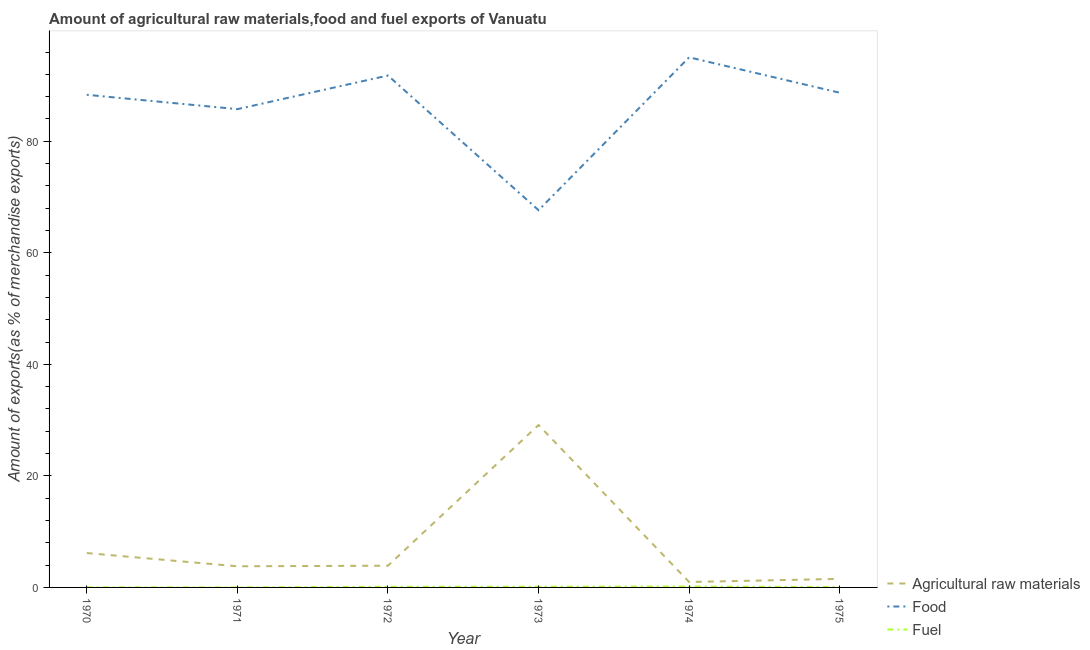How many different coloured lines are there?
Keep it short and to the point. 3. Is the number of lines equal to the number of legend labels?
Your response must be concise. Yes. What is the percentage of food exports in 1973?
Offer a terse response. 67.64. Across all years, what is the maximum percentage of raw materials exports?
Your answer should be compact. 29.12. Across all years, what is the minimum percentage of raw materials exports?
Offer a very short reply. 0.97. In which year was the percentage of fuel exports minimum?
Provide a short and direct response. 1971. What is the total percentage of raw materials exports in the graph?
Your response must be concise. 45.48. What is the difference between the percentage of raw materials exports in 1973 and that in 1974?
Your answer should be very brief. 28.15. What is the difference between the percentage of raw materials exports in 1973 and the percentage of fuel exports in 1972?
Your answer should be compact. 29.01. What is the average percentage of raw materials exports per year?
Ensure brevity in your answer.  7.58. In the year 1975, what is the difference between the percentage of food exports and percentage of fuel exports?
Give a very brief answer. 88.64. In how many years, is the percentage of fuel exports greater than 80 %?
Give a very brief answer. 0. What is the ratio of the percentage of food exports in 1971 to that in 1975?
Your answer should be very brief. 0.97. What is the difference between the highest and the second highest percentage of fuel exports?
Provide a succinct answer. 0.03. What is the difference between the highest and the lowest percentage of fuel exports?
Offer a very short reply. 0.17. In how many years, is the percentage of fuel exports greater than the average percentage of fuel exports taken over all years?
Offer a terse response. 3. Is the sum of the percentage of fuel exports in 1970 and 1975 greater than the maximum percentage of raw materials exports across all years?
Keep it short and to the point. No. Does the percentage of food exports monotonically increase over the years?
Offer a very short reply. No. Is the percentage of fuel exports strictly greater than the percentage of raw materials exports over the years?
Keep it short and to the point. No. How many lines are there?
Provide a short and direct response. 3. Does the graph contain any zero values?
Offer a very short reply. No. Does the graph contain grids?
Ensure brevity in your answer.  No. Where does the legend appear in the graph?
Provide a succinct answer. Bottom right. How are the legend labels stacked?
Make the answer very short. Vertical. What is the title of the graph?
Ensure brevity in your answer.  Amount of agricultural raw materials,food and fuel exports of Vanuatu. What is the label or title of the Y-axis?
Keep it short and to the point. Amount of exports(as % of merchandise exports). What is the Amount of exports(as % of merchandise exports) in Agricultural raw materials in 1970?
Make the answer very short. 6.16. What is the Amount of exports(as % of merchandise exports) in Food in 1970?
Offer a very short reply. 88.33. What is the Amount of exports(as % of merchandise exports) of Fuel in 1970?
Make the answer very short. 0.02. What is the Amount of exports(as % of merchandise exports) in Agricultural raw materials in 1971?
Offer a very short reply. 3.79. What is the Amount of exports(as % of merchandise exports) of Food in 1971?
Ensure brevity in your answer.  85.76. What is the Amount of exports(as % of merchandise exports) in Fuel in 1971?
Offer a very short reply. 0. What is the Amount of exports(as % of merchandise exports) of Agricultural raw materials in 1972?
Provide a short and direct response. 3.9. What is the Amount of exports(as % of merchandise exports) in Food in 1972?
Make the answer very short. 91.79. What is the Amount of exports(as % of merchandise exports) of Fuel in 1972?
Keep it short and to the point. 0.12. What is the Amount of exports(as % of merchandise exports) in Agricultural raw materials in 1973?
Provide a short and direct response. 29.12. What is the Amount of exports(as % of merchandise exports) in Food in 1973?
Provide a succinct answer. 67.64. What is the Amount of exports(as % of merchandise exports) in Fuel in 1973?
Keep it short and to the point. 0.14. What is the Amount of exports(as % of merchandise exports) of Agricultural raw materials in 1974?
Provide a succinct answer. 0.97. What is the Amount of exports(as % of merchandise exports) of Food in 1974?
Ensure brevity in your answer.  95.05. What is the Amount of exports(as % of merchandise exports) of Fuel in 1974?
Your response must be concise. 0.17. What is the Amount of exports(as % of merchandise exports) of Agricultural raw materials in 1975?
Your answer should be compact. 1.53. What is the Amount of exports(as % of merchandise exports) in Food in 1975?
Offer a very short reply. 88.7. What is the Amount of exports(as % of merchandise exports) in Fuel in 1975?
Make the answer very short. 0.07. Across all years, what is the maximum Amount of exports(as % of merchandise exports) of Agricultural raw materials?
Make the answer very short. 29.12. Across all years, what is the maximum Amount of exports(as % of merchandise exports) in Food?
Provide a succinct answer. 95.05. Across all years, what is the maximum Amount of exports(as % of merchandise exports) in Fuel?
Provide a short and direct response. 0.17. Across all years, what is the minimum Amount of exports(as % of merchandise exports) of Agricultural raw materials?
Give a very brief answer. 0.97. Across all years, what is the minimum Amount of exports(as % of merchandise exports) of Food?
Offer a very short reply. 67.64. Across all years, what is the minimum Amount of exports(as % of merchandise exports) in Fuel?
Offer a very short reply. 0. What is the total Amount of exports(as % of merchandise exports) of Agricultural raw materials in the graph?
Your answer should be very brief. 45.48. What is the total Amount of exports(as % of merchandise exports) in Food in the graph?
Provide a succinct answer. 517.29. What is the total Amount of exports(as % of merchandise exports) in Fuel in the graph?
Offer a very short reply. 0.51. What is the difference between the Amount of exports(as % of merchandise exports) in Agricultural raw materials in 1970 and that in 1971?
Make the answer very short. 2.37. What is the difference between the Amount of exports(as % of merchandise exports) in Food in 1970 and that in 1971?
Offer a terse response. 2.57. What is the difference between the Amount of exports(as % of merchandise exports) of Fuel in 1970 and that in 1971?
Ensure brevity in your answer.  0.02. What is the difference between the Amount of exports(as % of merchandise exports) in Agricultural raw materials in 1970 and that in 1972?
Ensure brevity in your answer.  2.27. What is the difference between the Amount of exports(as % of merchandise exports) of Food in 1970 and that in 1972?
Ensure brevity in your answer.  -3.46. What is the difference between the Amount of exports(as % of merchandise exports) in Fuel in 1970 and that in 1972?
Your answer should be very brief. -0.1. What is the difference between the Amount of exports(as % of merchandise exports) in Agricultural raw materials in 1970 and that in 1973?
Provide a short and direct response. -22.96. What is the difference between the Amount of exports(as % of merchandise exports) in Food in 1970 and that in 1973?
Your response must be concise. 20.69. What is the difference between the Amount of exports(as % of merchandise exports) in Fuel in 1970 and that in 1973?
Provide a short and direct response. -0.12. What is the difference between the Amount of exports(as % of merchandise exports) in Agricultural raw materials in 1970 and that in 1974?
Your answer should be compact. 5.19. What is the difference between the Amount of exports(as % of merchandise exports) of Food in 1970 and that in 1974?
Provide a short and direct response. -6.72. What is the difference between the Amount of exports(as % of merchandise exports) of Fuel in 1970 and that in 1974?
Provide a succinct answer. -0.15. What is the difference between the Amount of exports(as % of merchandise exports) in Agricultural raw materials in 1970 and that in 1975?
Your response must be concise. 4.63. What is the difference between the Amount of exports(as % of merchandise exports) of Food in 1970 and that in 1975?
Your answer should be very brief. -0.37. What is the difference between the Amount of exports(as % of merchandise exports) in Fuel in 1970 and that in 1975?
Provide a succinct answer. -0.05. What is the difference between the Amount of exports(as % of merchandise exports) in Agricultural raw materials in 1971 and that in 1972?
Ensure brevity in your answer.  -0.11. What is the difference between the Amount of exports(as % of merchandise exports) of Food in 1971 and that in 1972?
Offer a very short reply. -6.03. What is the difference between the Amount of exports(as % of merchandise exports) in Fuel in 1971 and that in 1972?
Your answer should be compact. -0.11. What is the difference between the Amount of exports(as % of merchandise exports) of Agricultural raw materials in 1971 and that in 1973?
Your response must be concise. -25.33. What is the difference between the Amount of exports(as % of merchandise exports) of Food in 1971 and that in 1973?
Ensure brevity in your answer.  18.12. What is the difference between the Amount of exports(as % of merchandise exports) of Fuel in 1971 and that in 1973?
Offer a very short reply. -0.13. What is the difference between the Amount of exports(as % of merchandise exports) in Agricultural raw materials in 1971 and that in 1974?
Ensure brevity in your answer.  2.82. What is the difference between the Amount of exports(as % of merchandise exports) in Food in 1971 and that in 1974?
Provide a succinct answer. -9.29. What is the difference between the Amount of exports(as % of merchandise exports) of Fuel in 1971 and that in 1974?
Give a very brief answer. -0.17. What is the difference between the Amount of exports(as % of merchandise exports) in Agricultural raw materials in 1971 and that in 1975?
Your response must be concise. 2.26. What is the difference between the Amount of exports(as % of merchandise exports) in Food in 1971 and that in 1975?
Offer a very short reply. -2.94. What is the difference between the Amount of exports(as % of merchandise exports) of Fuel in 1971 and that in 1975?
Provide a succinct answer. -0.07. What is the difference between the Amount of exports(as % of merchandise exports) of Agricultural raw materials in 1972 and that in 1973?
Make the answer very short. -25.23. What is the difference between the Amount of exports(as % of merchandise exports) of Food in 1972 and that in 1973?
Give a very brief answer. 24.15. What is the difference between the Amount of exports(as % of merchandise exports) in Fuel in 1972 and that in 1973?
Keep it short and to the point. -0.02. What is the difference between the Amount of exports(as % of merchandise exports) of Agricultural raw materials in 1972 and that in 1974?
Your answer should be compact. 2.93. What is the difference between the Amount of exports(as % of merchandise exports) in Food in 1972 and that in 1974?
Ensure brevity in your answer.  -3.26. What is the difference between the Amount of exports(as % of merchandise exports) of Fuel in 1972 and that in 1974?
Your answer should be compact. -0.05. What is the difference between the Amount of exports(as % of merchandise exports) in Agricultural raw materials in 1972 and that in 1975?
Your response must be concise. 2.36. What is the difference between the Amount of exports(as % of merchandise exports) of Food in 1972 and that in 1975?
Provide a short and direct response. 3.09. What is the difference between the Amount of exports(as % of merchandise exports) of Fuel in 1972 and that in 1975?
Provide a succinct answer. 0.05. What is the difference between the Amount of exports(as % of merchandise exports) in Agricultural raw materials in 1973 and that in 1974?
Offer a terse response. 28.15. What is the difference between the Amount of exports(as % of merchandise exports) of Food in 1973 and that in 1974?
Provide a short and direct response. -27.41. What is the difference between the Amount of exports(as % of merchandise exports) in Fuel in 1973 and that in 1974?
Your answer should be compact. -0.03. What is the difference between the Amount of exports(as % of merchandise exports) of Agricultural raw materials in 1973 and that in 1975?
Your response must be concise. 27.59. What is the difference between the Amount of exports(as % of merchandise exports) of Food in 1973 and that in 1975?
Your answer should be very brief. -21.06. What is the difference between the Amount of exports(as % of merchandise exports) in Fuel in 1973 and that in 1975?
Your response must be concise. 0.07. What is the difference between the Amount of exports(as % of merchandise exports) of Agricultural raw materials in 1974 and that in 1975?
Offer a terse response. -0.56. What is the difference between the Amount of exports(as % of merchandise exports) in Food in 1974 and that in 1975?
Give a very brief answer. 6.35. What is the difference between the Amount of exports(as % of merchandise exports) of Fuel in 1974 and that in 1975?
Make the answer very short. 0.1. What is the difference between the Amount of exports(as % of merchandise exports) of Agricultural raw materials in 1970 and the Amount of exports(as % of merchandise exports) of Food in 1971?
Your answer should be compact. -79.6. What is the difference between the Amount of exports(as % of merchandise exports) in Agricultural raw materials in 1970 and the Amount of exports(as % of merchandise exports) in Fuel in 1971?
Offer a very short reply. 6.16. What is the difference between the Amount of exports(as % of merchandise exports) of Food in 1970 and the Amount of exports(as % of merchandise exports) of Fuel in 1971?
Ensure brevity in your answer.  88.33. What is the difference between the Amount of exports(as % of merchandise exports) in Agricultural raw materials in 1970 and the Amount of exports(as % of merchandise exports) in Food in 1972?
Keep it short and to the point. -85.63. What is the difference between the Amount of exports(as % of merchandise exports) of Agricultural raw materials in 1970 and the Amount of exports(as % of merchandise exports) of Fuel in 1972?
Your response must be concise. 6.05. What is the difference between the Amount of exports(as % of merchandise exports) in Food in 1970 and the Amount of exports(as % of merchandise exports) in Fuel in 1972?
Offer a terse response. 88.22. What is the difference between the Amount of exports(as % of merchandise exports) of Agricultural raw materials in 1970 and the Amount of exports(as % of merchandise exports) of Food in 1973?
Offer a terse response. -61.48. What is the difference between the Amount of exports(as % of merchandise exports) of Agricultural raw materials in 1970 and the Amount of exports(as % of merchandise exports) of Fuel in 1973?
Keep it short and to the point. 6.03. What is the difference between the Amount of exports(as % of merchandise exports) of Food in 1970 and the Amount of exports(as % of merchandise exports) of Fuel in 1973?
Your answer should be compact. 88.2. What is the difference between the Amount of exports(as % of merchandise exports) of Agricultural raw materials in 1970 and the Amount of exports(as % of merchandise exports) of Food in 1974?
Ensure brevity in your answer.  -88.89. What is the difference between the Amount of exports(as % of merchandise exports) in Agricultural raw materials in 1970 and the Amount of exports(as % of merchandise exports) in Fuel in 1974?
Your answer should be very brief. 6. What is the difference between the Amount of exports(as % of merchandise exports) of Food in 1970 and the Amount of exports(as % of merchandise exports) of Fuel in 1974?
Your answer should be very brief. 88.17. What is the difference between the Amount of exports(as % of merchandise exports) of Agricultural raw materials in 1970 and the Amount of exports(as % of merchandise exports) of Food in 1975?
Your answer should be very brief. -82.54. What is the difference between the Amount of exports(as % of merchandise exports) in Agricultural raw materials in 1970 and the Amount of exports(as % of merchandise exports) in Fuel in 1975?
Provide a short and direct response. 6.1. What is the difference between the Amount of exports(as % of merchandise exports) of Food in 1970 and the Amount of exports(as % of merchandise exports) of Fuel in 1975?
Your response must be concise. 88.27. What is the difference between the Amount of exports(as % of merchandise exports) in Agricultural raw materials in 1971 and the Amount of exports(as % of merchandise exports) in Food in 1972?
Offer a terse response. -88. What is the difference between the Amount of exports(as % of merchandise exports) of Agricultural raw materials in 1971 and the Amount of exports(as % of merchandise exports) of Fuel in 1972?
Provide a succinct answer. 3.67. What is the difference between the Amount of exports(as % of merchandise exports) of Food in 1971 and the Amount of exports(as % of merchandise exports) of Fuel in 1972?
Your answer should be compact. 85.65. What is the difference between the Amount of exports(as % of merchandise exports) in Agricultural raw materials in 1971 and the Amount of exports(as % of merchandise exports) in Food in 1973?
Offer a very short reply. -63.85. What is the difference between the Amount of exports(as % of merchandise exports) of Agricultural raw materials in 1971 and the Amount of exports(as % of merchandise exports) of Fuel in 1973?
Your response must be concise. 3.65. What is the difference between the Amount of exports(as % of merchandise exports) of Food in 1971 and the Amount of exports(as % of merchandise exports) of Fuel in 1973?
Make the answer very short. 85.63. What is the difference between the Amount of exports(as % of merchandise exports) of Agricultural raw materials in 1971 and the Amount of exports(as % of merchandise exports) of Food in 1974?
Your answer should be compact. -91.26. What is the difference between the Amount of exports(as % of merchandise exports) in Agricultural raw materials in 1971 and the Amount of exports(as % of merchandise exports) in Fuel in 1974?
Give a very brief answer. 3.62. What is the difference between the Amount of exports(as % of merchandise exports) in Food in 1971 and the Amount of exports(as % of merchandise exports) in Fuel in 1974?
Provide a succinct answer. 85.59. What is the difference between the Amount of exports(as % of merchandise exports) of Agricultural raw materials in 1971 and the Amount of exports(as % of merchandise exports) of Food in 1975?
Keep it short and to the point. -84.91. What is the difference between the Amount of exports(as % of merchandise exports) of Agricultural raw materials in 1971 and the Amount of exports(as % of merchandise exports) of Fuel in 1975?
Your answer should be very brief. 3.72. What is the difference between the Amount of exports(as % of merchandise exports) of Food in 1971 and the Amount of exports(as % of merchandise exports) of Fuel in 1975?
Ensure brevity in your answer.  85.69. What is the difference between the Amount of exports(as % of merchandise exports) of Agricultural raw materials in 1972 and the Amount of exports(as % of merchandise exports) of Food in 1973?
Offer a terse response. -63.75. What is the difference between the Amount of exports(as % of merchandise exports) in Agricultural raw materials in 1972 and the Amount of exports(as % of merchandise exports) in Fuel in 1973?
Make the answer very short. 3.76. What is the difference between the Amount of exports(as % of merchandise exports) of Food in 1972 and the Amount of exports(as % of merchandise exports) of Fuel in 1973?
Provide a succinct answer. 91.66. What is the difference between the Amount of exports(as % of merchandise exports) in Agricultural raw materials in 1972 and the Amount of exports(as % of merchandise exports) in Food in 1974?
Keep it short and to the point. -91.16. What is the difference between the Amount of exports(as % of merchandise exports) in Agricultural raw materials in 1972 and the Amount of exports(as % of merchandise exports) in Fuel in 1974?
Offer a terse response. 3.73. What is the difference between the Amount of exports(as % of merchandise exports) of Food in 1972 and the Amount of exports(as % of merchandise exports) of Fuel in 1974?
Provide a succinct answer. 91.62. What is the difference between the Amount of exports(as % of merchandise exports) in Agricultural raw materials in 1972 and the Amount of exports(as % of merchandise exports) in Food in 1975?
Ensure brevity in your answer.  -84.81. What is the difference between the Amount of exports(as % of merchandise exports) of Agricultural raw materials in 1972 and the Amount of exports(as % of merchandise exports) of Fuel in 1975?
Offer a terse response. 3.83. What is the difference between the Amount of exports(as % of merchandise exports) of Food in 1972 and the Amount of exports(as % of merchandise exports) of Fuel in 1975?
Your answer should be compact. 91.72. What is the difference between the Amount of exports(as % of merchandise exports) in Agricultural raw materials in 1973 and the Amount of exports(as % of merchandise exports) in Food in 1974?
Your response must be concise. -65.93. What is the difference between the Amount of exports(as % of merchandise exports) of Agricultural raw materials in 1973 and the Amount of exports(as % of merchandise exports) of Fuel in 1974?
Make the answer very short. 28.95. What is the difference between the Amount of exports(as % of merchandise exports) in Food in 1973 and the Amount of exports(as % of merchandise exports) in Fuel in 1974?
Make the answer very short. 67.47. What is the difference between the Amount of exports(as % of merchandise exports) in Agricultural raw materials in 1973 and the Amount of exports(as % of merchandise exports) in Food in 1975?
Give a very brief answer. -59.58. What is the difference between the Amount of exports(as % of merchandise exports) in Agricultural raw materials in 1973 and the Amount of exports(as % of merchandise exports) in Fuel in 1975?
Keep it short and to the point. 29.05. What is the difference between the Amount of exports(as % of merchandise exports) in Food in 1973 and the Amount of exports(as % of merchandise exports) in Fuel in 1975?
Your answer should be compact. 67.57. What is the difference between the Amount of exports(as % of merchandise exports) of Agricultural raw materials in 1974 and the Amount of exports(as % of merchandise exports) of Food in 1975?
Provide a short and direct response. -87.73. What is the difference between the Amount of exports(as % of merchandise exports) in Agricultural raw materials in 1974 and the Amount of exports(as % of merchandise exports) in Fuel in 1975?
Offer a very short reply. 0.9. What is the difference between the Amount of exports(as % of merchandise exports) in Food in 1974 and the Amount of exports(as % of merchandise exports) in Fuel in 1975?
Provide a succinct answer. 94.98. What is the average Amount of exports(as % of merchandise exports) of Agricultural raw materials per year?
Offer a terse response. 7.58. What is the average Amount of exports(as % of merchandise exports) in Food per year?
Ensure brevity in your answer.  86.21. What is the average Amount of exports(as % of merchandise exports) in Fuel per year?
Keep it short and to the point. 0.08. In the year 1970, what is the difference between the Amount of exports(as % of merchandise exports) in Agricultural raw materials and Amount of exports(as % of merchandise exports) in Food?
Provide a short and direct response. -82.17. In the year 1970, what is the difference between the Amount of exports(as % of merchandise exports) of Agricultural raw materials and Amount of exports(as % of merchandise exports) of Fuel?
Ensure brevity in your answer.  6.14. In the year 1970, what is the difference between the Amount of exports(as % of merchandise exports) in Food and Amount of exports(as % of merchandise exports) in Fuel?
Make the answer very short. 88.31. In the year 1971, what is the difference between the Amount of exports(as % of merchandise exports) of Agricultural raw materials and Amount of exports(as % of merchandise exports) of Food?
Your answer should be compact. -81.97. In the year 1971, what is the difference between the Amount of exports(as % of merchandise exports) of Agricultural raw materials and Amount of exports(as % of merchandise exports) of Fuel?
Your answer should be compact. 3.79. In the year 1971, what is the difference between the Amount of exports(as % of merchandise exports) of Food and Amount of exports(as % of merchandise exports) of Fuel?
Provide a succinct answer. 85.76. In the year 1972, what is the difference between the Amount of exports(as % of merchandise exports) of Agricultural raw materials and Amount of exports(as % of merchandise exports) of Food?
Offer a very short reply. -87.9. In the year 1972, what is the difference between the Amount of exports(as % of merchandise exports) of Agricultural raw materials and Amount of exports(as % of merchandise exports) of Fuel?
Ensure brevity in your answer.  3.78. In the year 1972, what is the difference between the Amount of exports(as % of merchandise exports) in Food and Amount of exports(as % of merchandise exports) in Fuel?
Keep it short and to the point. 91.68. In the year 1973, what is the difference between the Amount of exports(as % of merchandise exports) of Agricultural raw materials and Amount of exports(as % of merchandise exports) of Food?
Offer a terse response. -38.52. In the year 1973, what is the difference between the Amount of exports(as % of merchandise exports) in Agricultural raw materials and Amount of exports(as % of merchandise exports) in Fuel?
Ensure brevity in your answer.  28.99. In the year 1973, what is the difference between the Amount of exports(as % of merchandise exports) of Food and Amount of exports(as % of merchandise exports) of Fuel?
Ensure brevity in your answer.  67.51. In the year 1974, what is the difference between the Amount of exports(as % of merchandise exports) in Agricultural raw materials and Amount of exports(as % of merchandise exports) in Food?
Keep it short and to the point. -94.08. In the year 1974, what is the difference between the Amount of exports(as % of merchandise exports) in Agricultural raw materials and Amount of exports(as % of merchandise exports) in Fuel?
Provide a short and direct response. 0.8. In the year 1974, what is the difference between the Amount of exports(as % of merchandise exports) in Food and Amount of exports(as % of merchandise exports) in Fuel?
Your answer should be compact. 94.88. In the year 1975, what is the difference between the Amount of exports(as % of merchandise exports) of Agricultural raw materials and Amount of exports(as % of merchandise exports) of Food?
Offer a terse response. -87.17. In the year 1975, what is the difference between the Amount of exports(as % of merchandise exports) of Agricultural raw materials and Amount of exports(as % of merchandise exports) of Fuel?
Make the answer very short. 1.46. In the year 1975, what is the difference between the Amount of exports(as % of merchandise exports) of Food and Amount of exports(as % of merchandise exports) of Fuel?
Offer a very short reply. 88.64. What is the ratio of the Amount of exports(as % of merchandise exports) of Agricultural raw materials in 1970 to that in 1971?
Offer a terse response. 1.63. What is the ratio of the Amount of exports(as % of merchandise exports) in Fuel in 1970 to that in 1971?
Give a very brief answer. 10.53. What is the ratio of the Amount of exports(as % of merchandise exports) in Agricultural raw materials in 1970 to that in 1972?
Keep it short and to the point. 1.58. What is the ratio of the Amount of exports(as % of merchandise exports) in Food in 1970 to that in 1972?
Your answer should be very brief. 0.96. What is the ratio of the Amount of exports(as % of merchandise exports) of Fuel in 1970 to that in 1972?
Offer a very short reply. 0.17. What is the ratio of the Amount of exports(as % of merchandise exports) in Agricultural raw materials in 1970 to that in 1973?
Give a very brief answer. 0.21. What is the ratio of the Amount of exports(as % of merchandise exports) in Food in 1970 to that in 1973?
Keep it short and to the point. 1.31. What is the ratio of the Amount of exports(as % of merchandise exports) in Fuel in 1970 to that in 1973?
Offer a very short reply. 0.14. What is the ratio of the Amount of exports(as % of merchandise exports) of Agricultural raw materials in 1970 to that in 1974?
Give a very brief answer. 6.35. What is the ratio of the Amount of exports(as % of merchandise exports) in Food in 1970 to that in 1974?
Your answer should be very brief. 0.93. What is the ratio of the Amount of exports(as % of merchandise exports) of Fuel in 1970 to that in 1974?
Keep it short and to the point. 0.12. What is the ratio of the Amount of exports(as % of merchandise exports) in Agricultural raw materials in 1970 to that in 1975?
Your answer should be very brief. 4.02. What is the ratio of the Amount of exports(as % of merchandise exports) in Food in 1970 to that in 1975?
Make the answer very short. 1. What is the ratio of the Amount of exports(as % of merchandise exports) in Fuel in 1970 to that in 1975?
Make the answer very short. 0.29. What is the ratio of the Amount of exports(as % of merchandise exports) of Agricultural raw materials in 1971 to that in 1972?
Your answer should be very brief. 0.97. What is the ratio of the Amount of exports(as % of merchandise exports) in Food in 1971 to that in 1972?
Keep it short and to the point. 0.93. What is the ratio of the Amount of exports(as % of merchandise exports) in Fuel in 1971 to that in 1972?
Keep it short and to the point. 0.02. What is the ratio of the Amount of exports(as % of merchandise exports) of Agricultural raw materials in 1971 to that in 1973?
Provide a short and direct response. 0.13. What is the ratio of the Amount of exports(as % of merchandise exports) of Food in 1971 to that in 1973?
Keep it short and to the point. 1.27. What is the ratio of the Amount of exports(as % of merchandise exports) of Fuel in 1971 to that in 1973?
Offer a very short reply. 0.01. What is the ratio of the Amount of exports(as % of merchandise exports) of Agricultural raw materials in 1971 to that in 1974?
Offer a very short reply. 3.91. What is the ratio of the Amount of exports(as % of merchandise exports) of Food in 1971 to that in 1974?
Your answer should be very brief. 0.9. What is the ratio of the Amount of exports(as % of merchandise exports) of Fuel in 1971 to that in 1974?
Offer a very short reply. 0.01. What is the ratio of the Amount of exports(as % of merchandise exports) in Agricultural raw materials in 1971 to that in 1975?
Provide a succinct answer. 2.47. What is the ratio of the Amount of exports(as % of merchandise exports) in Food in 1971 to that in 1975?
Offer a very short reply. 0.97. What is the ratio of the Amount of exports(as % of merchandise exports) of Fuel in 1971 to that in 1975?
Make the answer very short. 0.03. What is the ratio of the Amount of exports(as % of merchandise exports) of Agricultural raw materials in 1972 to that in 1973?
Your response must be concise. 0.13. What is the ratio of the Amount of exports(as % of merchandise exports) in Food in 1972 to that in 1973?
Your answer should be compact. 1.36. What is the ratio of the Amount of exports(as % of merchandise exports) in Fuel in 1972 to that in 1973?
Keep it short and to the point. 0.85. What is the ratio of the Amount of exports(as % of merchandise exports) in Agricultural raw materials in 1972 to that in 1974?
Your answer should be very brief. 4.02. What is the ratio of the Amount of exports(as % of merchandise exports) in Food in 1972 to that in 1974?
Your response must be concise. 0.97. What is the ratio of the Amount of exports(as % of merchandise exports) in Fuel in 1972 to that in 1974?
Provide a succinct answer. 0.69. What is the ratio of the Amount of exports(as % of merchandise exports) in Agricultural raw materials in 1972 to that in 1975?
Give a very brief answer. 2.54. What is the ratio of the Amount of exports(as % of merchandise exports) in Food in 1972 to that in 1975?
Your answer should be compact. 1.03. What is the ratio of the Amount of exports(as % of merchandise exports) in Fuel in 1972 to that in 1975?
Give a very brief answer. 1.68. What is the ratio of the Amount of exports(as % of merchandise exports) of Agricultural raw materials in 1973 to that in 1974?
Your response must be concise. 30.02. What is the ratio of the Amount of exports(as % of merchandise exports) of Food in 1973 to that in 1974?
Give a very brief answer. 0.71. What is the ratio of the Amount of exports(as % of merchandise exports) of Fuel in 1973 to that in 1974?
Make the answer very short. 0.81. What is the ratio of the Amount of exports(as % of merchandise exports) of Agricultural raw materials in 1973 to that in 1975?
Give a very brief answer. 19. What is the ratio of the Amount of exports(as % of merchandise exports) of Food in 1973 to that in 1975?
Keep it short and to the point. 0.76. What is the ratio of the Amount of exports(as % of merchandise exports) in Fuel in 1973 to that in 1975?
Provide a short and direct response. 1.97. What is the ratio of the Amount of exports(as % of merchandise exports) in Agricultural raw materials in 1974 to that in 1975?
Your answer should be very brief. 0.63. What is the ratio of the Amount of exports(as % of merchandise exports) of Food in 1974 to that in 1975?
Make the answer very short. 1.07. What is the ratio of the Amount of exports(as % of merchandise exports) of Fuel in 1974 to that in 1975?
Provide a succinct answer. 2.45. What is the difference between the highest and the second highest Amount of exports(as % of merchandise exports) in Agricultural raw materials?
Offer a very short reply. 22.96. What is the difference between the highest and the second highest Amount of exports(as % of merchandise exports) in Food?
Provide a short and direct response. 3.26. What is the difference between the highest and the second highest Amount of exports(as % of merchandise exports) of Fuel?
Make the answer very short. 0.03. What is the difference between the highest and the lowest Amount of exports(as % of merchandise exports) of Agricultural raw materials?
Keep it short and to the point. 28.15. What is the difference between the highest and the lowest Amount of exports(as % of merchandise exports) in Food?
Provide a short and direct response. 27.41. What is the difference between the highest and the lowest Amount of exports(as % of merchandise exports) in Fuel?
Offer a very short reply. 0.17. 